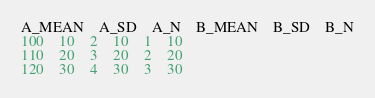<code> <loc_0><loc_0><loc_500><loc_500><_SQL_>A_MEAN	A_SD	A_N	B_MEAN	B_SD	B_N
100	10	2	10	1	10
110	20	3	20	2	20
120	30	4	30	3	30
</code> 